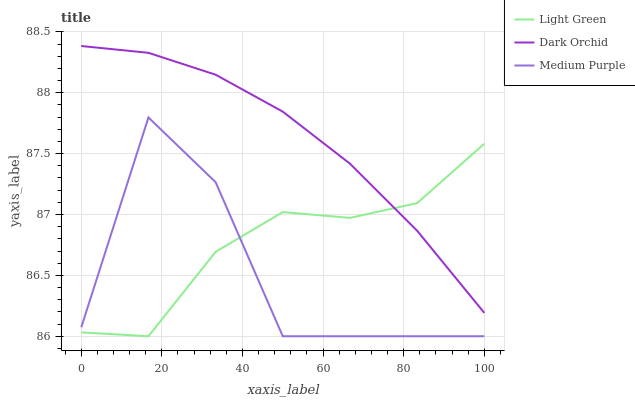Does Medium Purple have the minimum area under the curve?
Answer yes or no. Yes. Does Dark Orchid have the maximum area under the curve?
Answer yes or no. Yes. Does Light Green have the minimum area under the curve?
Answer yes or no. No. Does Light Green have the maximum area under the curve?
Answer yes or no. No. Is Dark Orchid the smoothest?
Answer yes or no. Yes. Is Medium Purple the roughest?
Answer yes or no. Yes. Is Light Green the smoothest?
Answer yes or no. No. Is Light Green the roughest?
Answer yes or no. No. Does Dark Orchid have the lowest value?
Answer yes or no. No. Does Dark Orchid have the highest value?
Answer yes or no. Yes. Does Light Green have the highest value?
Answer yes or no. No. Is Medium Purple less than Dark Orchid?
Answer yes or no. Yes. Is Dark Orchid greater than Medium Purple?
Answer yes or no. Yes. Does Medium Purple intersect Light Green?
Answer yes or no. Yes. Is Medium Purple less than Light Green?
Answer yes or no. No. Is Medium Purple greater than Light Green?
Answer yes or no. No. Does Medium Purple intersect Dark Orchid?
Answer yes or no. No. 